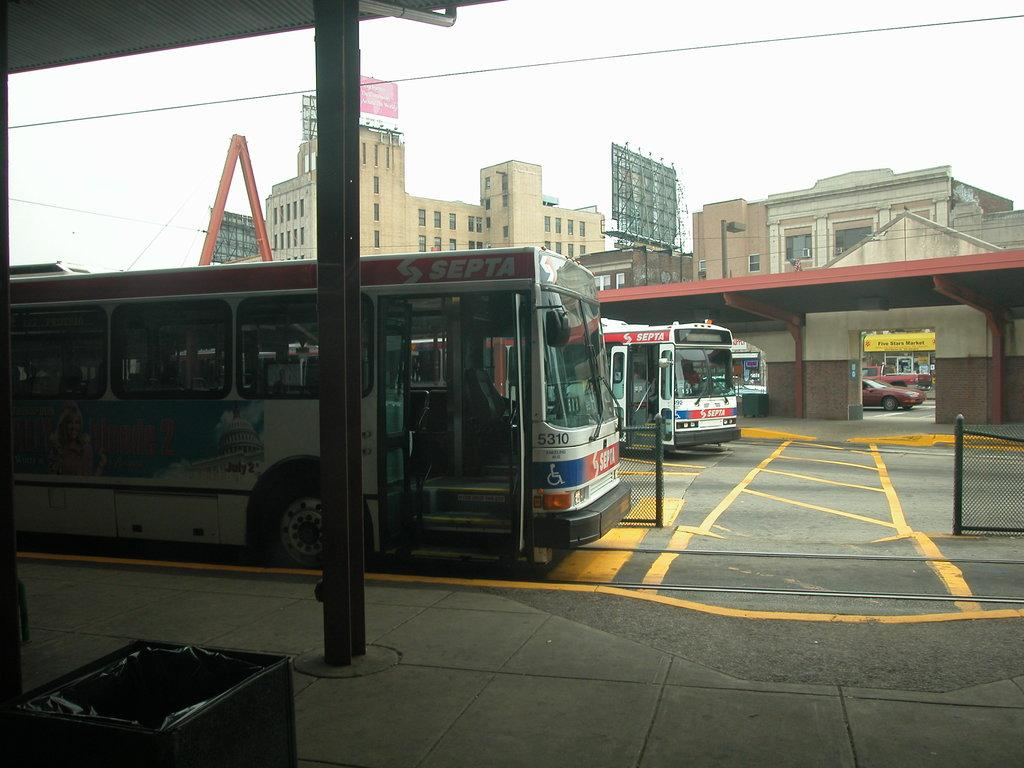What type of vehicles can be seen in the image? There are buses in the image. What structures are present in the image? There are sheds in the image. What can be seen in the distance in the image? There are buildings visible in the background of the image. What song is the farmer singing in the image? There is no farmer or song present in the image. What kind of trouble is the bus driver experiencing in the image? There is no indication of trouble or a bus driver in the image. 